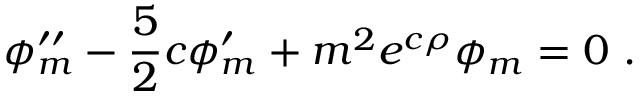<formula> <loc_0><loc_0><loc_500><loc_500>\phi _ { m } ^ { \prime \prime } - \frac { 5 } { 2 } c \phi _ { m } ^ { \prime } + m ^ { 2 } e ^ { c \rho } \phi _ { m } = 0 .</formula> 